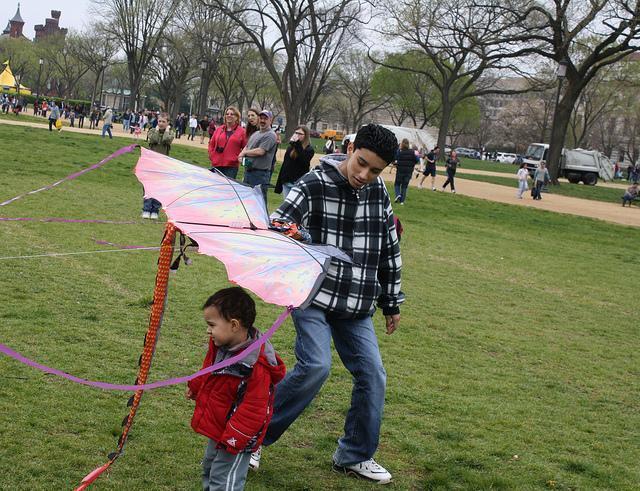How many people are visible?
Give a very brief answer. 4. 